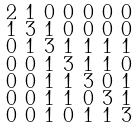<formula> <loc_0><loc_0><loc_500><loc_500>\begin{smallmatrix} 2 & 1 & 0 & 0 & 0 & 0 & 0 \\ 1 & 3 & 1 & 0 & 0 & 0 & 0 \\ 0 & 1 & 3 & 1 & 1 & 1 & 1 \\ 0 & 0 & 1 & 3 & 1 & 1 & 0 \\ 0 & 0 & 1 & 1 & 3 & 0 & 1 \\ 0 & 0 & 1 & 1 & 0 & 3 & 1 \\ 0 & 0 & 1 & 0 & 1 & 1 & 3 \end{smallmatrix}</formula> 